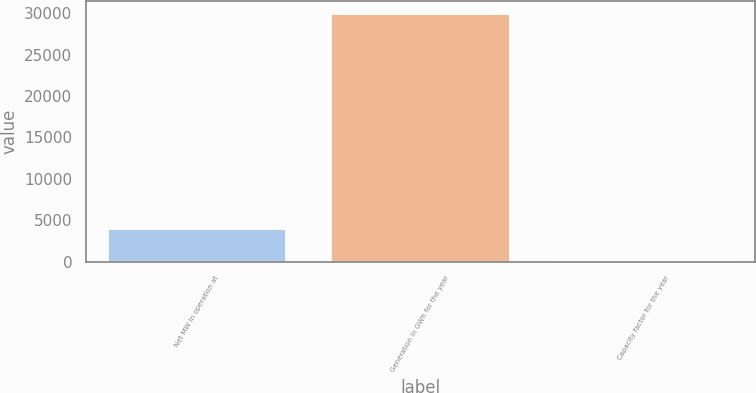<chart> <loc_0><loc_0><loc_500><loc_500><bar_chart><fcel>Net MW in operation at<fcel>Generation in GWh for the year<fcel>Capacity factor for the year<nl><fcel>3955<fcel>29953<fcel>93<nl></chart> 